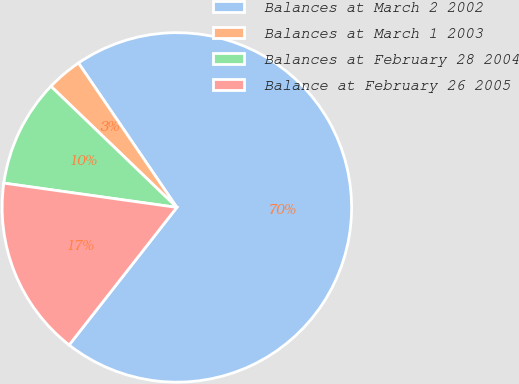Convert chart to OTSL. <chart><loc_0><loc_0><loc_500><loc_500><pie_chart><fcel>Balances at March 2 2002<fcel>Balances at March 1 2003<fcel>Balances at February 28 2004<fcel>Balance at February 26 2005<nl><fcel>70.1%<fcel>3.29%<fcel>9.97%<fcel>16.65%<nl></chart> 